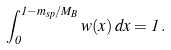<formula> <loc_0><loc_0><loc_500><loc_500>\int _ { 0 } ^ { 1 - m _ { s p } / M _ { B } } w ( x ) \, d x = 1 \, .</formula> 